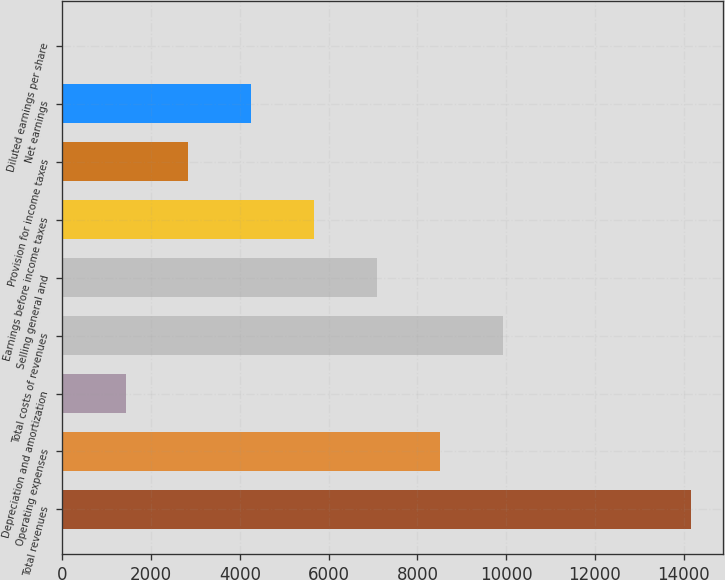Convert chart to OTSL. <chart><loc_0><loc_0><loc_500><loc_500><bar_chart><fcel>Total revenues<fcel>Operating expenses<fcel>Depreciation and amortization<fcel>Total costs of revenues<fcel>Selling general and<fcel>Earnings before income taxes<fcel>Provision for income taxes<fcel>Net earnings<fcel>Diluted earnings per share<nl><fcel>14175.2<fcel>8507.24<fcel>1422.24<fcel>9924.24<fcel>7090.24<fcel>5673.24<fcel>2839.24<fcel>4256.24<fcel>5.24<nl></chart> 